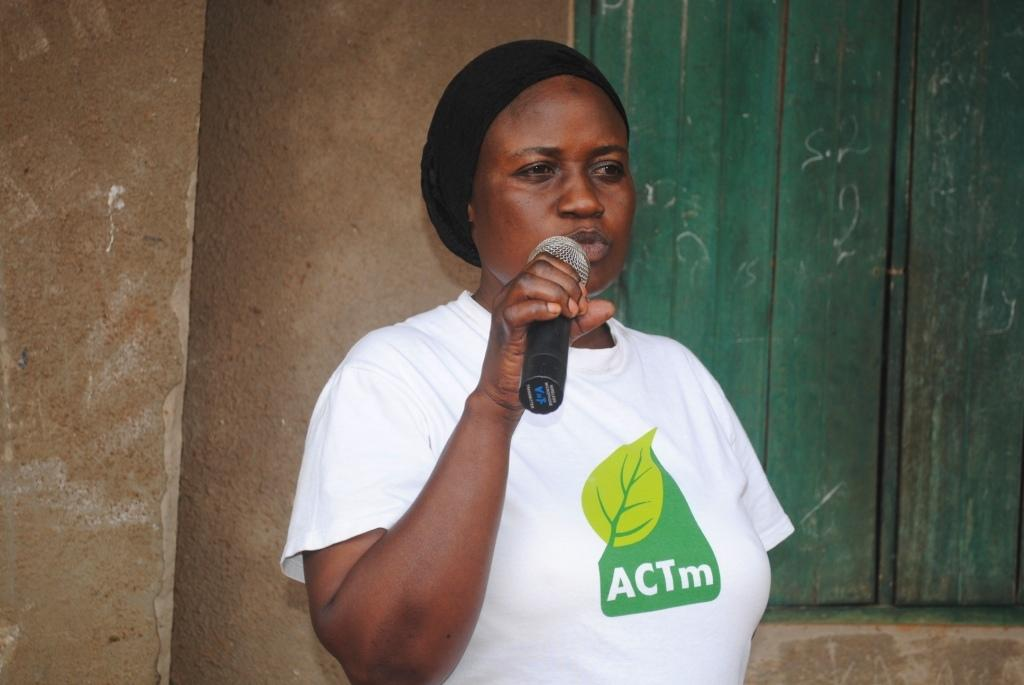Who is the main subject in the image? There is a woman in the image. What is the woman holding in her hand? The woman is holding a microphone in her hand. What can be seen in the background of the image? There is a wall and a window in the background of the image. Can you determine the time of day when the image was taken? The image was likely taken during the day, as there is no indication of darkness or artificial lighting. What type of brain can be seen in the image? There is no brain visible in the image; it features a woman holding a microphone. What fact about the party can be determined from the image? There is no party depicted in the image, so no facts about a party can be determined. 